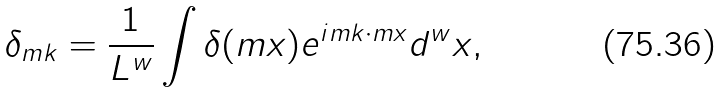Convert formula to latex. <formula><loc_0><loc_0><loc_500><loc_500>\delta _ { m { k } } = \frac { 1 } { L ^ { w } } \int \delta ( m { x } ) e ^ { i m { k } \cdot m { x } } d ^ { w } x ,</formula> 